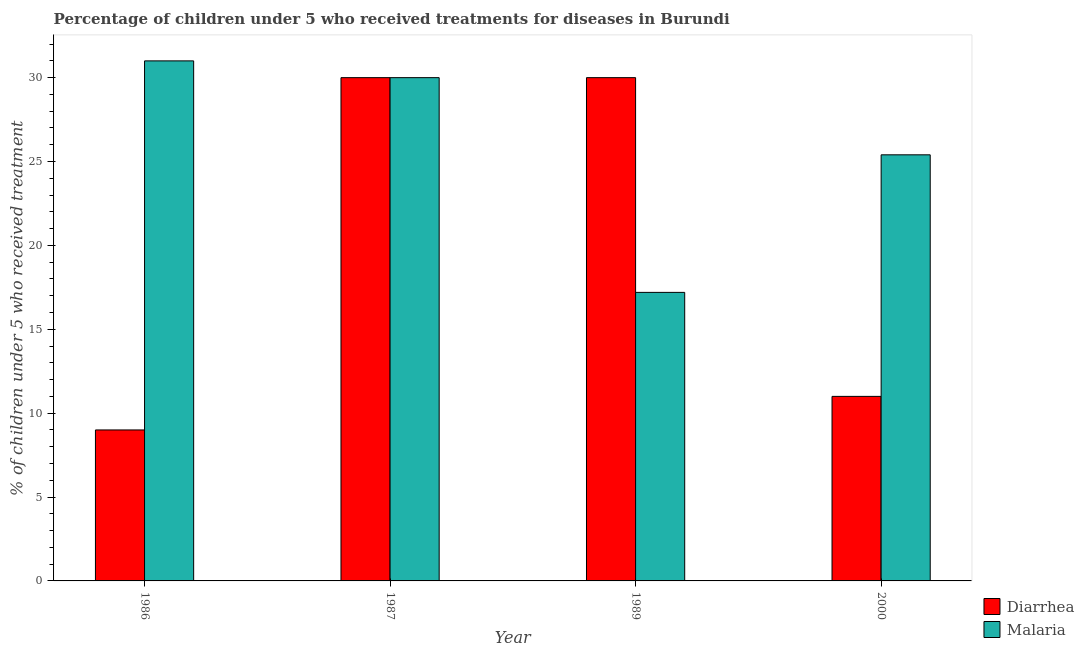How many different coloured bars are there?
Provide a succinct answer. 2. How many groups of bars are there?
Your answer should be very brief. 4. Are the number of bars on each tick of the X-axis equal?
Offer a very short reply. Yes. How many bars are there on the 4th tick from the right?
Keep it short and to the point. 2. What is the label of the 2nd group of bars from the left?
Provide a short and direct response. 1987. What is the percentage of children who received treatment for diarrhoea in 1989?
Your response must be concise. 30. Across all years, what is the minimum percentage of children who received treatment for malaria?
Ensure brevity in your answer.  17.2. What is the total percentage of children who received treatment for malaria in the graph?
Provide a succinct answer. 103.6. What is the difference between the percentage of children who received treatment for malaria in 1987 and that in 2000?
Provide a succinct answer. 4.6. What is the average percentage of children who received treatment for diarrhoea per year?
Offer a very short reply. 20. In the year 1986, what is the difference between the percentage of children who received treatment for diarrhoea and percentage of children who received treatment for malaria?
Your answer should be very brief. 0. What is the ratio of the percentage of children who received treatment for diarrhoea in 1986 to that in 2000?
Your answer should be very brief. 0.82. What is the difference between the highest and the second highest percentage of children who received treatment for diarrhoea?
Provide a succinct answer. 0. Is the sum of the percentage of children who received treatment for malaria in 1989 and 2000 greater than the maximum percentage of children who received treatment for diarrhoea across all years?
Offer a very short reply. Yes. What does the 2nd bar from the left in 2000 represents?
Make the answer very short. Malaria. What does the 1st bar from the right in 1987 represents?
Provide a short and direct response. Malaria. Are all the bars in the graph horizontal?
Give a very brief answer. No. How many years are there in the graph?
Your answer should be compact. 4. Are the values on the major ticks of Y-axis written in scientific E-notation?
Your answer should be compact. No. Does the graph contain grids?
Make the answer very short. No. What is the title of the graph?
Your answer should be very brief. Percentage of children under 5 who received treatments for diseases in Burundi. What is the label or title of the Y-axis?
Your answer should be very brief. % of children under 5 who received treatment. What is the % of children under 5 who received treatment of Diarrhea in 1986?
Keep it short and to the point. 9. What is the % of children under 5 who received treatment of Diarrhea in 1987?
Make the answer very short. 30. What is the % of children under 5 who received treatment of Malaria in 1987?
Give a very brief answer. 30. What is the % of children under 5 who received treatment in Malaria in 1989?
Keep it short and to the point. 17.2. What is the % of children under 5 who received treatment of Diarrhea in 2000?
Offer a terse response. 11. What is the % of children under 5 who received treatment in Malaria in 2000?
Offer a terse response. 25.4. Across all years, what is the maximum % of children under 5 who received treatment of Diarrhea?
Ensure brevity in your answer.  30. What is the total % of children under 5 who received treatment in Malaria in the graph?
Ensure brevity in your answer.  103.6. What is the difference between the % of children under 5 who received treatment of Diarrhea in 1986 and that in 1987?
Your response must be concise. -21. What is the difference between the % of children under 5 who received treatment in Malaria in 1986 and that in 2000?
Your response must be concise. 5.6. What is the difference between the % of children under 5 who received treatment of Diarrhea in 1987 and that in 2000?
Your answer should be very brief. 19. What is the difference between the % of children under 5 who received treatment in Diarrhea in 1989 and that in 2000?
Give a very brief answer. 19. What is the difference between the % of children under 5 who received treatment of Diarrhea in 1986 and the % of children under 5 who received treatment of Malaria in 2000?
Ensure brevity in your answer.  -16.4. What is the difference between the % of children under 5 who received treatment in Diarrhea in 1987 and the % of children under 5 who received treatment in Malaria in 2000?
Provide a short and direct response. 4.6. What is the difference between the % of children under 5 who received treatment of Diarrhea in 1989 and the % of children under 5 who received treatment of Malaria in 2000?
Keep it short and to the point. 4.6. What is the average % of children under 5 who received treatment in Malaria per year?
Offer a terse response. 25.9. In the year 1986, what is the difference between the % of children under 5 who received treatment of Diarrhea and % of children under 5 who received treatment of Malaria?
Offer a terse response. -22. In the year 1987, what is the difference between the % of children under 5 who received treatment in Diarrhea and % of children under 5 who received treatment in Malaria?
Make the answer very short. 0. In the year 1989, what is the difference between the % of children under 5 who received treatment of Diarrhea and % of children under 5 who received treatment of Malaria?
Provide a succinct answer. 12.8. In the year 2000, what is the difference between the % of children under 5 who received treatment in Diarrhea and % of children under 5 who received treatment in Malaria?
Offer a very short reply. -14.4. What is the ratio of the % of children under 5 who received treatment in Diarrhea in 1986 to that in 1989?
Ensure brevity in your answer.  0.3. What is the ratio of the % of children under 5 who received treatment of Malaria in 1986 to that in 1989?
Make the answer very short. 1.8. What is the ratio of the % of children under 5 who received treatment of Diarrhea in 1986 to that in 2000?
Provide a short and direct response. 0.82. What is the ratio of the % of children under 5 who received treatment in Malaria in 1986 to that in 2000?
Your answer should be very brief. 1.22. What is the ratio of the % of children under 5 who received treatment of Malaria in 1987 to that in 1989?
Provide a short and direct response. 1.74. What is the ratio of the % of children under 5 who received treatment in Diarrhea in 1987 to that in 2000?
Keep it short and to the point. 2.73. What is the ratio of the % of children under 5 who received treatment of Malaria in 1987 to that in 2000?
Provide a succinct answer. 1.18. What is the ratio of the % of children under 5 who received treatment in Diarrhea in 1989 to that in 2000?
Your answer should be compact. 2.73. What is the ratio of the % of children under 5 who received treatment of Malaria in 1989 to that in 2000?
Provide a short and direct response. 0.68. What is the difference between the highest and the second highest % of children under 5 who received treatment in Diarrhea?
Keep it short and to the point. 0. What is the difference between the highest and the second highest % of children under 5 who received treatment of Malaria?
Give a very brief answer. 1. What is the difference between the highest and the lowest % of children under 5 who received treatment of Diarrhea?
Give a very brief answer. 21. 